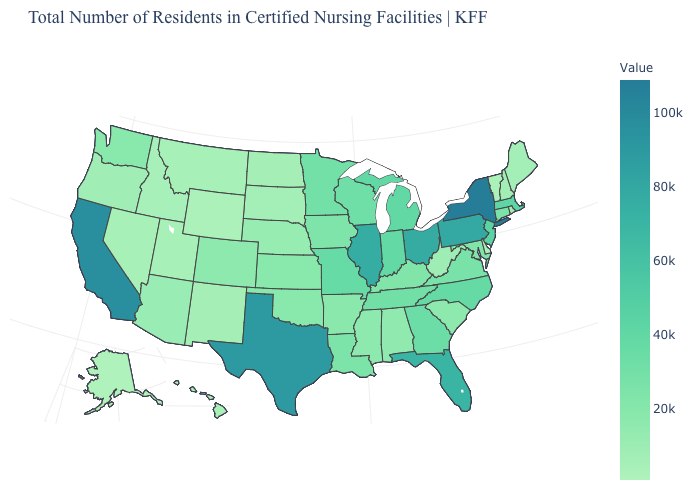Does the map have missing data?
Give a very brief answer. No. Among the states that border Virginia , which have the highest value?
Keep it brief. North Carolina. Which states have the lowest value in the MidWest?
Write a very short answer. North Dakota. Which states have the lowest value in the West?
Keep it brief. Alaska. Which states hav the highest value in the Northeast?
Write a very short answer. New York. Among the states that border Nevada , does California have the highest value?
Concise answer only. Yes. Is the legend a continuous bar?
Short answer required. Yes. Which states have the lowest value in the USA?
Quick response, please. Alaska. 